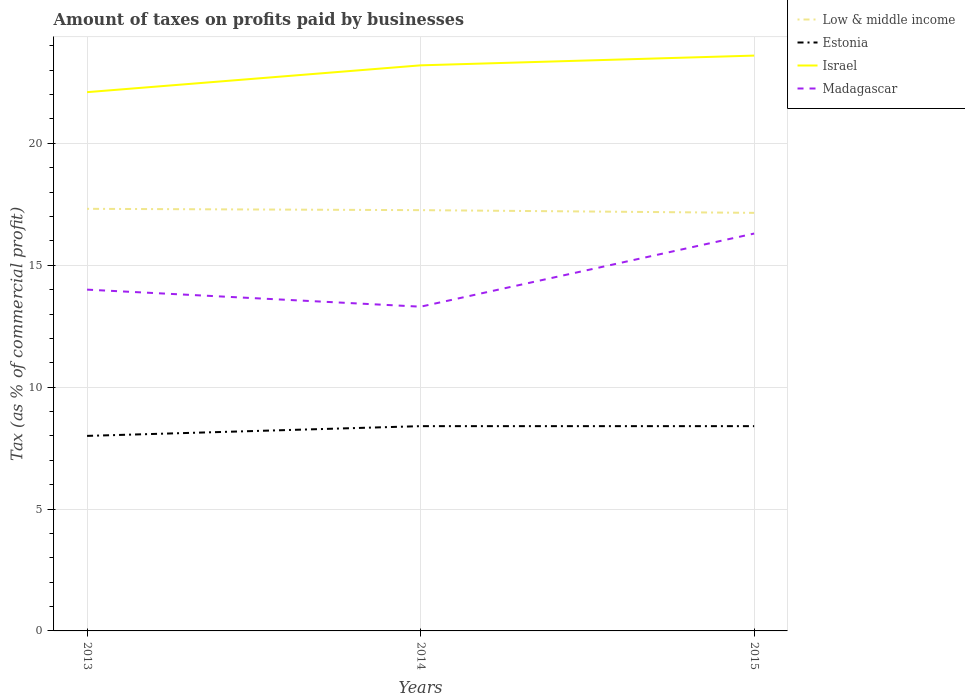How many different coloured lines are there?
Your answer should be very brief. 4. Does the line corresponding to Estonia intersect with the line corresponding to Madagascar?
Make the answer very short. No. Across all years, what is the maximum percentage of taxes paid by businesses in Low & middle income?
Offer a very short reply. 17.15. In which year was the percentage of taxes paid by businesses in Madagascar maximum?
Offer a terse response. 2014. What is the total percentage of taxes paid by businesses in Israel in the graph?
Your answer should be very brief. -0.4. What is the difference between the highest and the second highest percentage of taxes paid by businesses in Madagascar?
Make the answer very short. 3. Is the percentage of taxes paid by businesses in Low & middle income strictly greater than the percentage of taxes paid by businesses in Israel over the years?
Offer a terse response. Yes. Are the values on the major ticks of Y-axis written in scientific E-notation?
Your answer should be compact. No. Does the graph contain grids?
Your response must be concise. Yes. How are the legend labels stacked?
Make the answer very short. Vertical. What is the title of the graph?
Provide a succinct answer. Amount of taxes on profits paid by businesses. Does "Other small states" appear as one of the legend labels in the graph?
Make the answer very short. No. What is the label or title of the X-axis?
Ensure brevity in your answer.  Years. What is the label or title of the Y-axis?
Offer a very short reply. Tax (as % of commercial profit). What is the Tax (as % of commercial profit) in Low & middle income in 2013?
Your answer should be compact. 17.31. What is the Tax (as % of commercial profit) in Israel in 2013?
Your answer should be compact. 22.1. What is the Tax (as % of commercial profit) in Low & middle income in 2014?
Provide a succinct answer. 17.26. What is the Tax (as % of commercial profit) in Estonia in 2014?
Give a very brief answer. 8.4. What is the Tax (as % of commercial profit) in Israel in 2014?
Keep it short and to the point. 23.2. What is the Tax (as % of commercial profit) in Madagascar in 2014?
Your answer should be very brief. 13.3. What is the Tax (as % of commercial profit) in Low & middle income in 2015?
Offer a very short reply. 17.15. What is the Tax (as % of commercial profit) of Estonia in 2015?
Offer a terse response. 8.4. What is the Tax (as % of commercial profit) in Israel in 2015?
Provide a succinct answer. 23.6. Across all years, what is the maximum Tax (as % of commercial profit) of Low & middle income?
Offer a terse response. 17.31. Across all years, what is the maximum Tax (as % of commercial profit) in Israel?
Provide a short and direct response. 23.6. Across all years, what is the maximum Tax (as % of commercial profit) of Madagascar?
Provide a short and direct response. 16.3. Across all years, what is the minimum Tax (as % of commercial profit) in Low & middle income?
Offer a terse response. 17.15. Across all years, what is the minimum Tax (as % of commercial profit) of Israel?
Offer a terse response. 22.1. Across all years, what is the minimum Tax (as % of commercial profit) in Madagascar?
Your response must be concise. 13.3. What is the total Tax (as % of commercial profit) of Low & middle income in the graph?
Give a very brief answer. 51.72. What is the total Tax (as % of commercial profit) of Estonia in the graph?
Your response must be concise. 24.8. What is the total Tax (as % of commercial profit) in Israel in the graph?
Your response must be concise. 68.9. What is the total Tax (as % of commercial profit) in Madagascar in the graph?
Ensure brevity in your answer.  43.6. What is the difference between the Tax (as % of commercial profit) in Low & middle income in 2013 and that in 2014?
Keep it short and to the point. 0.05. What is the difference between the Tax (as % of commercial profit) in Israel in 2013 and that in 2014?
Offer a terse response. -1.1. What is the difference between the Tax (as % of commercial profit) in Low & middle income in 2013 and that in 2015?
Offer a very short reply. 0.17. What is the difference between the Tax (as % of commercial profit) of Estonia in 2013 and that in 2015?
Your response must be concise. -0.4. What is the difference between the Tax (as % of commercial profit) of Israel in 2013 and that in 2015?
Your response must be concise. -1.5. What is the difference between the Tax (as % of commercial profit) in Madagascar in 2013 and that in 2015?
Give a very brief answer. -2.3. What is the difference between the Tax (as % of commercial profit) of Low & middle income in 2014 and that in 2015?
Ensure brevity in your answer.  0.11. What is the difference between the Tax (as % of commercial profit) of Estonia in 2014 and that in 2015?
Keep it short and to the point. 0. What is the difference between the Tax (as % of commercial profit) of Israel in 2014 and that in 2015?
Your answer should be very brief. -0.4. What is the difference between the Tax (as % of commercial profit) in Low & middle income in 2013 and the Tax (as % of commercial profit) in Estonia in 2014?
Give a very brief answer. 8.91. What is the difference between the Tax (as % of commercial profit) in Low & middle income in 2013 and the Tax (as % of commercial profit) in Israel in 2014?
Offer a terse response. -5.89. What is the difference between the Tax (as % of commercial profit) in Low & middle income in 2013 and the Tax (as % of commercial profit) in Madagascar in 2014?
Your answer should be compact. 4.01. What is the difference between the Tax (as % of commercial profit) in Estonia in 2013 and the Tax (as % of commercial profit) in Israel in 2014?
Your response must be concise. -15.2. What is the difference between the Tax (as % of commercial profit) of Estonia in 2013 and the Tax (as % of commercial profit) of Madagascar in 2014?
Ensure brevity in your answer.  -5.3. What is the difference between the Tax (as % of commercial profit) of Low & middle income in 2013 and the Tax (as % of commercial profit) of Estonia in 2015?
Provide a short and direct response. 8.91. What is the difference between the Tax (as % of commercial profit) in Low & middle income in 2013 and the Tax (as % of commercial profit) in Israel in 2015?
Your answer should be very brief. -6.29. What is the difference between the Tax (as % of commercial profit) in Low & middle income in 2013 and the Tax (as % of commercial profit) in Madagascar in 2015?
Your answer should be very brief. 1.01. What is the difference between the Tax (as % of commercial profit) in Estonia in 2013 and the Tax (as % of commercial profit) in Israel in 2015?
Offer a very short reply. -15.6. What is the difference between the Tax (as % of commercial profit) of Estonia in 2013 and the Tax (as % of commercial profit) of Madagascar in 2015?
Your answer should be very brief. -8.3. What is the difference between the Tax (as % of commercial profit) in Low & middle income in 2014 and the Tax (as % of commercial profit) in Estonia in 2015?
Your answer should be compact. 8.86. What is the difference between the Tax (as % of commercial profit) in Low & middle income in 2014 and the Tax (as % of commercial profit) in Israel in 2015?
Provide a short and direct response. -6.34. What is the difference between the Tax (as % of commercial profit) of Low & middle income in 2014 and the Tax (as % of commercial profit) of Madagascar in 2015?
Offer a very short reply. 0.96. What is the difference between the Tax (as % of commercial profit) of Estonia in 2014 and the Tax (as % of commercial profit) of Israel in 2015?
Ensure brevity in your answer.  -15.2. What is the difference between the Tax (as % of commercial profit) of Israel in 2014 and the Tax (as % of commercial profit) of Madagascar in 2015?
Your answer should be very brief. 6.9. What is the average Tax (as % of commercial profit) in Low & middle income per year?
Offer a terse response. 17.24. What is the average Tax (as % of commercial profit) of Estonia per year?
Give a very brief answer. 8.27. What is the average Tax (as % of commercial profit) in Israel per year?
Ensure brevity in your answer.  22.97. What is the average Tax (as % of commercial profit) of Madagascar per year?
Offer a terse response. 14.53. In the year 2013, what is the difference between the Tax (as % of commercial profit) of Low & middle income and Tax (as % of commercial profit) of Estonia?
Your answer should be very brief. 9.31. In the year 2013, what is the difference between the Tax (as % of commercial profit) of Low & middle income and Tax (as % of commercial profit) of Israel?
Ensure brevity in your answer.  -4.79. In the year 2013, what is the difference between the Tax (as % of commercial profit) of Low & middle income and Tax (as % of commercial profit) of Madagascar?
Ensure brevity in your answer.  3.31. In the year 2013, what is the difference between the Tax (as % of commercial profit) of Estonia and Tax (as % of commercial profit) of Israel?
Offer a terse response. -14.1. In the year 2013, what is the difference between the Tax (as % of commercial profit) in Israel and Tax (as % of commercial profit) in Madagascar?
Give a very brief answer. 8.1. In the year 2014, what is the difference between the Tax (as % of commercial profit) of Low & middle income and Tax (as % of commercial profit) of Estonia?
Your answer should be compact. 8.86. In the year 2014, what is the difference between the Tax (as % of commercial profit) of Low & middle income and Tax (as % of commercial profit) of Israel?
Make the answer very short. -5.94. In the year 2014, what is the difference between the Tax (as % of commercial profit) in Low & middle income and Tax (as % of commercial profit) in Madagascar?
Your response must be concise. 3.96. In the year 2014, what is the difference between the Tax (as % of commercial profit) in Estonia and Tax (as % of commercial profit) in Israel?
Keep it short and to the point. -14.8. In the year 2014, what is the difference between the Tax (as % of commercial profit) of Israel and Tax (as % of commercial profit) of Madagascar?
Make the answer very short. 9.9. In the year 2015, what is the difference between the Tax (as % of commercial profit) in Low & middle income and Tax (as % of commercial profit) in Estonia?
Make the answer very short. 8.75. In the year 2015, what is the difference between the Tax (as % of commercial profit) in Low & middle income and Tax (as % of commercial profit) in Israel?
Provide a short and direct response. -6.45. In the year 2015, what is the difference between the Tax (as % of commercial profit) in Low & middle income and Tax (as % of commercial profit) in Madagascar?
Offer a very short reply. 0.85. In the year 2015, what is the difference between the Tax (as % of commercial profit) of Estonia and Tax (as % of commercial profit) of Israel?
Offer a very short reply. -15.2. In the year 2015, what is the difference between the Tax (as % of commercial profit) of Estonia and Tax (as % of commercial profit) of Madagascar?
Offer a terse response. -7.9. In the year 2015, what is the difference between the Tax (as % of commercial profit) in Israel and Tax (as % of commercial profit) in Madagascar?
Ensure brevity in your answer.  7.3. What is the ratio of the Tax (as % of commercial profit) in Israel in 2013 to that in 2014?
Ensure brevity in your answer.  0.95. What is the ratio of the Tax (as % of commercial profit) in Madagascar in 2013 to that in 2014?
Your response must be concise. 1.05. What is the ratio of the Tax (as % of commercial profit) in Low & middle income in 2013 to that in 2015?
Your answer should be very brief. 1.01. What is the ratio of the Tax (as % of commercial profit) of Estonia in 2013 to that in 2015?
Offer a terse response. 0.95. What is the ratio of the Tax (as % of commercial profit) of Israel in 2013 to that in 2015?
Your answer should be very brief. 0.94. What is the ratio of the Tax (as % of commercial profit) of Madagascar in 2013 to that in 2015?
Keep it short and to the point. 0.86. What is the ratio of the Tax (as % of commercial profit) in Low & middle income in 2014 to that in 2015?
Give a very brief answer. 1.01. What is the ratio of the Tax (as % of commercial profit) of Estonia in 2014 to that in 2015?
Your answer should be very brief. 1. What is the ratio of the Tax (as % of commercial profit) in Israel in 2014 to that in 2015?
Keep it short and to the point. 0.98. What is the ratio of the Tax (as % of commercial profit) in Madagascar in 2014 to that in 2015?
Offer a terse response. 0.82. What is the difference between the highest and the second highest Tax (as % of commercial profit) in Low & middle income?
Give a very brief answer. 0.05. What is the difference between the highest and the second highest Tax (as % of commercial profit) of Estonia?
Offer a terse response. 0. What is the difference between the highest and the lowest Tax (as % of commercial profit) in Low & middle income?
Offer a terse response. 0.17. What is the difference between the highest and the lowest Tax (as % of commercial profit) in Estonia?
Your answer should be very brief. 0.4. What is the difference between the highest and the lowest Tax (as % of commercial profit) in Madagascar?
Your answer should be very brief. 3. 